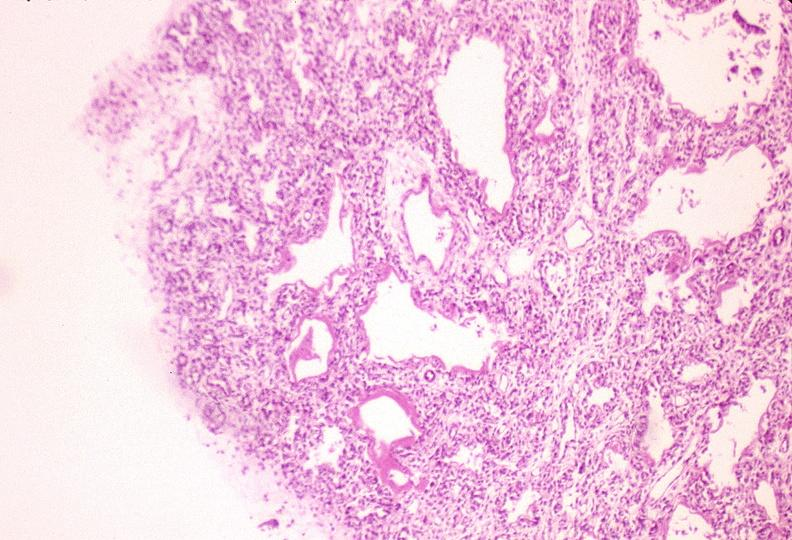what is present?
Answer the question using a single word or phrase. Respiratory 